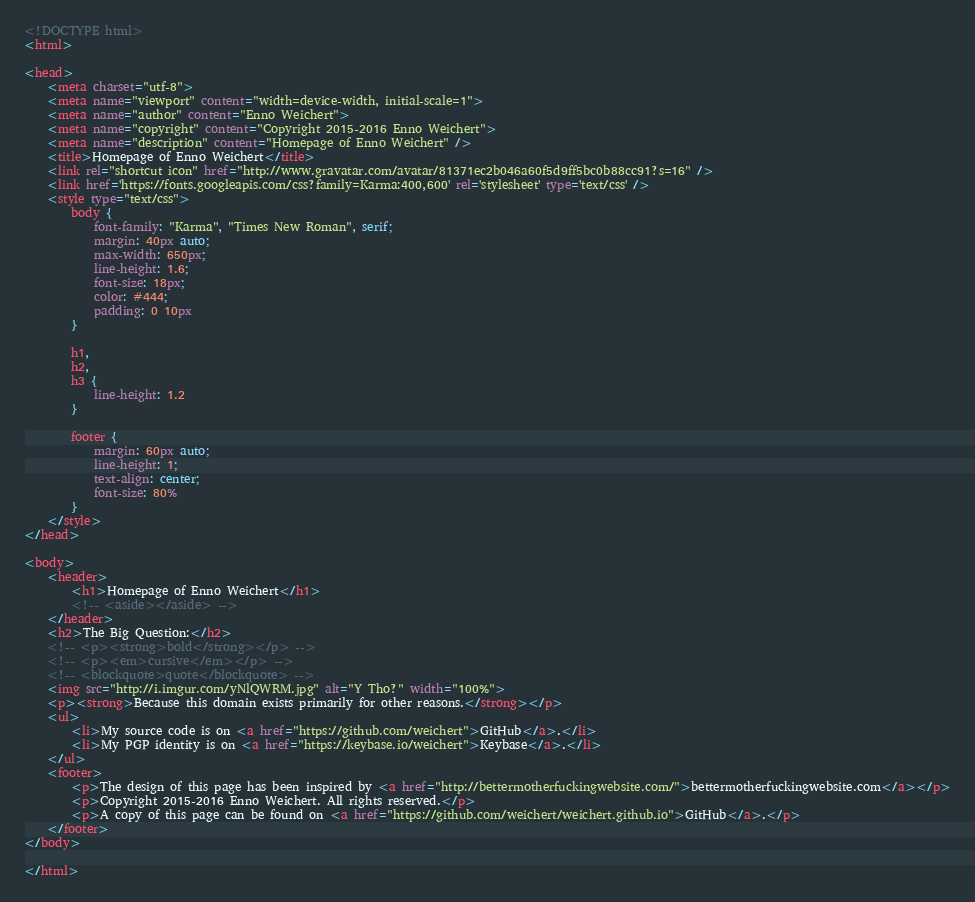Convert code to text. <code><loc_0><loc_0><loc_500><loc_500><_HTML_><!DOCTYPE html>
<html>

<head>
    <meta charset="utf-8">
    <meta name="viewport" content="width=device-width, initial-scale=1">
    <meta name="author" content="Enno Weichert">
    <meta name="copyright" content="Copyright 2015-2016 Enno Weichert">
    <meta name="description" content="Homepage of Enno Weichert" />
    <title>Homepage of Enno Weichert</title>
    <link rel="shortcut icon" href="http://www.gravatar.com/avatar/81371ec2b046a60f5d9ff5bc0b88cc91?s=16" />
    <link href='https://fonts.googleapis.com/css?family=Karma:400,600' rel='stylesheet' type='text/css' />
    <style type="text/css">
        body {
            font-family: "Karma", "Times New Roman", serif;
            margin: 40px auto;
            max-width: 650px;
            line-height: 1.6;
            font-size: 18px;
            color: #444;
            padding: 0 10px
        }

        h1,
        h2,
        h3 {
            line-height: 1.2
        }

        footer {
            margin: 60px auto;
            line-height: 1;
            text-align: center;
            font-size: 80%
        }
    </style>
</head>

<body>
    <header>
        <h1>Homepage of Enno Weichert</h1>
        <!-- <aside></aside> -->
    </header>
    <h2>The Big Question:</h2>
    <!-- <p><strong>bold</strong></p> -->
    <!-- <p><em>cursive</em></p> -->
    <!-- <blockquote>quote</blockquote> -->
    <img src="http://i.imgur.com/yNlQWRM.jpg" alt="Y Tho?" width="100%">
    <p><strong>Because this domain exists primarily for other reasons.</strong></p>
    <ul>
        <li>My source code is on <a href="https://github.com/weichert">GitHub</a>.</li>
        <li>My PGP identity is on <a href="https://keybase.io/weichert">Keybase</a>.</li>
    </ul>
    <footer>
        <p>The design of this page has been inspired by <a href="http://bettermotherfuckingwebsite.com/">bettermotherfuckingwebsite.com</a></p>
        <p>Copyright 2015-2016 Enno Weichert. All rights reserved.</p>
        <p>A copy of this page can be found on <a href="https://github.com/weichert/weichert.github.io">GitHub</a>.</p>
    </footer>
</body>

</html>
</code> 